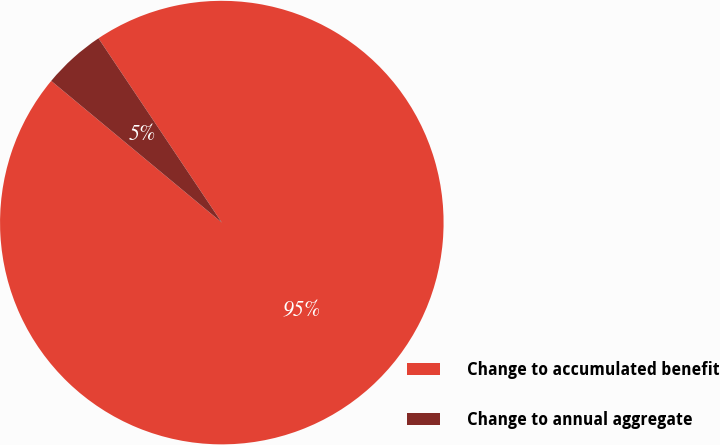<chart> <loc_0><loc_0><loc_500><loc_500><pie_chart><fcel>Change to accumulated benefit<fcel>Change to annual aggregate<nl><fcel>95.42%<fcel>4.58%<nl></chart> 